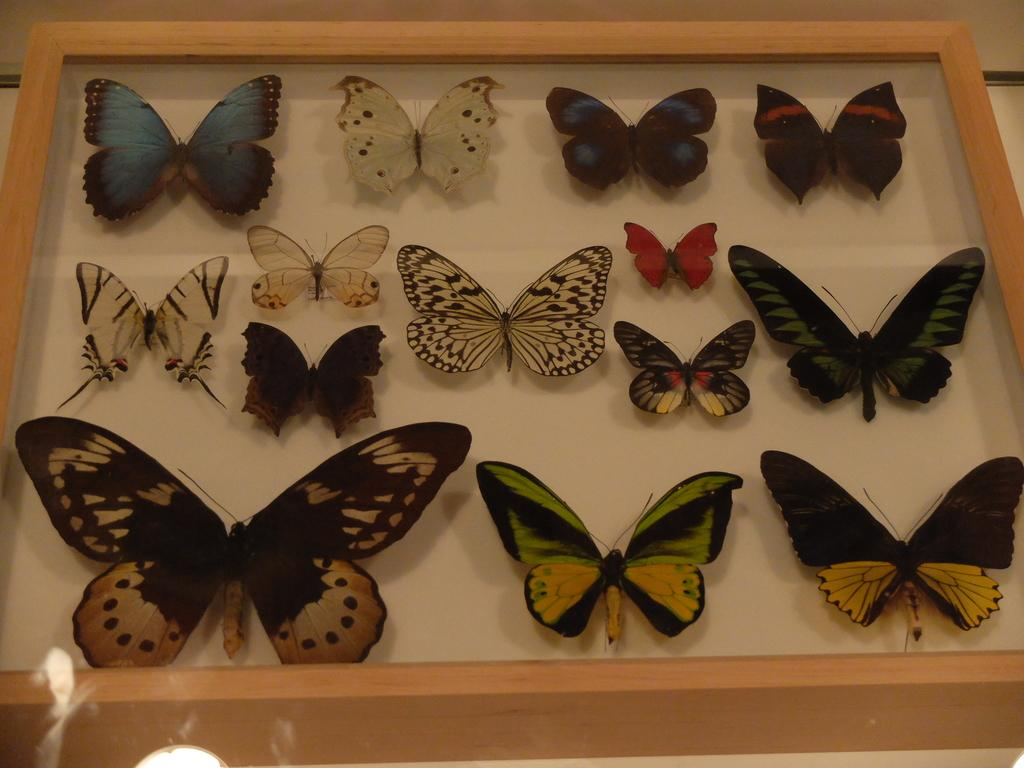What type of animals can be seen in the image? There are butterflies in the image. Where are the butterflies located? The butterflies are in a box. What type of pen is being used to draw the butterflies in the image? There is no pen or drawing activity present in the image; it features real butterflies in a box. 